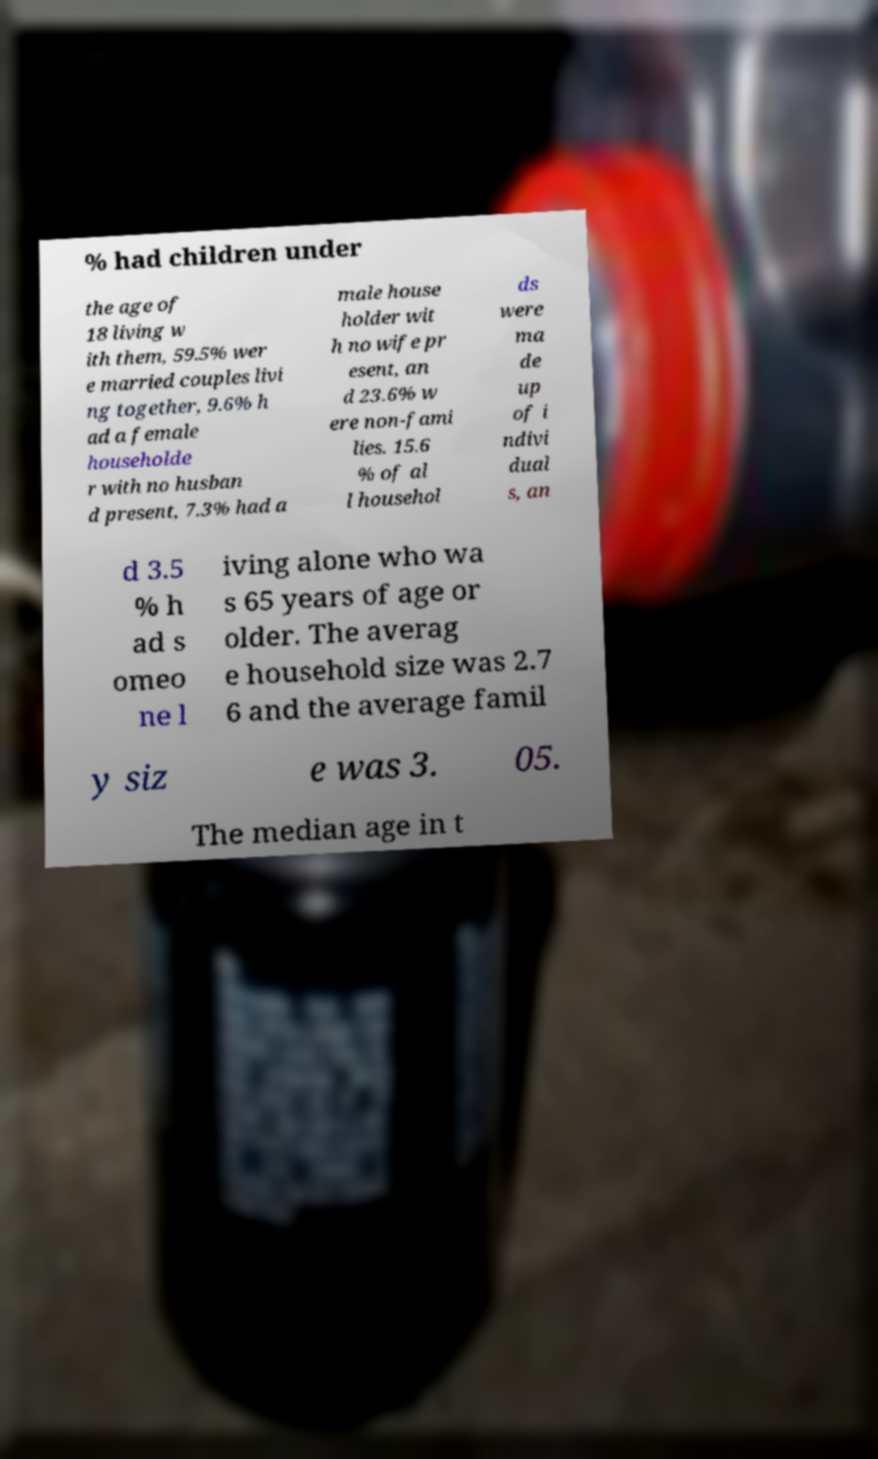Could you assist in decoding the text presented in this image and type it out clearly? % had children under the age of 18 living w ith them, 59.5% wer e married couples livi ng together, 9.6% h ad a female householde r with no husban d present, 7.3% had a male house holder wit h no wife pr esent, an d 23.6% w ere non-fami lies. 15.6 % of al l househol ds were ma de up of i ndivi dual s, an d 3.5 % h ad s omeo ne l iving alone who wa s 65 years of age or older. The averag e household size was 2.7 6 and the average famil y siz e was 3. 05. The median age in t 